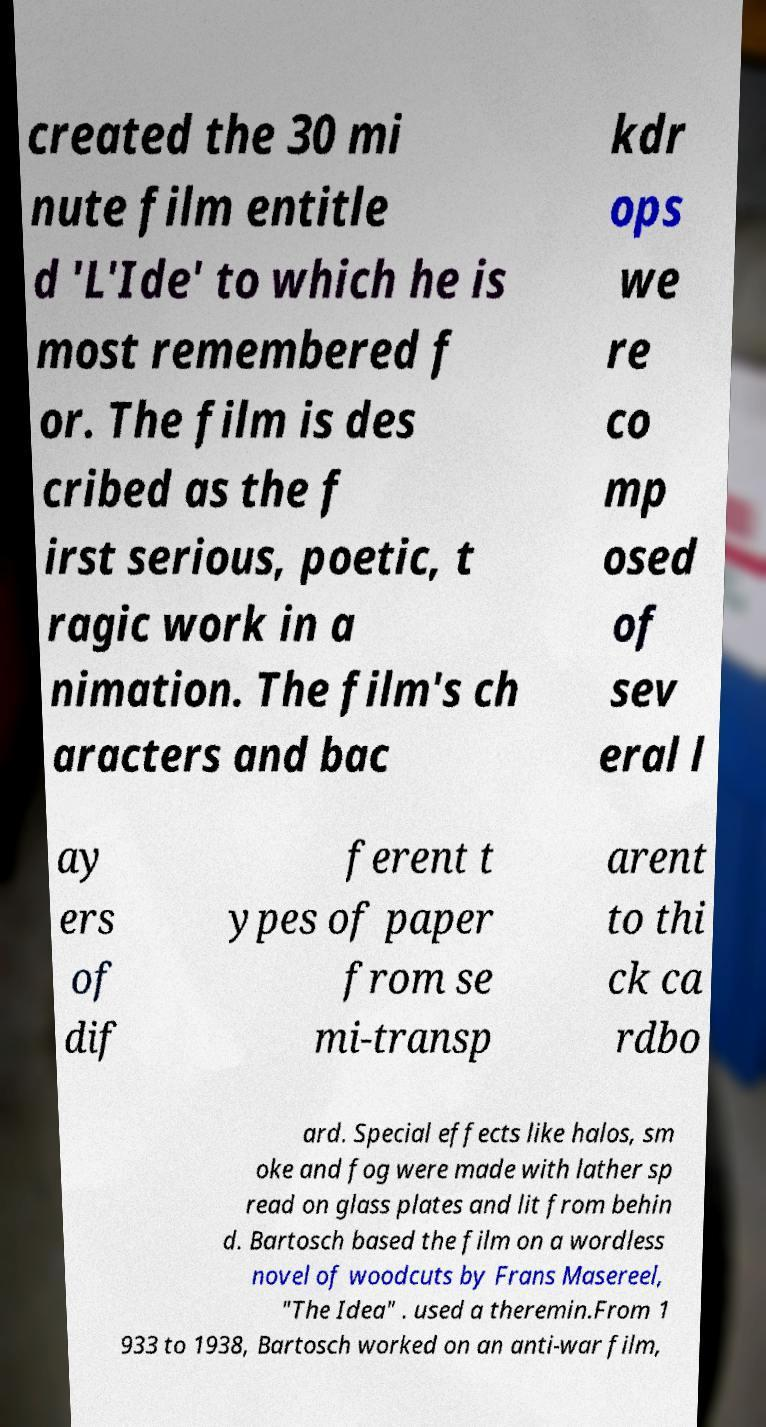There's text embedded in this image that I need extracted. Can you transcribe it verbatim? created the 30 mi nute film entitle d 'L'Ide' to which he is most remembered f or. The film is des cribed as the f irst serious, poetic, t ragic work in a nimation. The film's ch aracters and bac kdr ops we re co mp osed of sev eral l ay ers of dif ferent t ypes of paper from se mi-transp arent to thi ck ca rdbo ard. Special effects like halos, sm oke and fog were made with lather sp read on glass plates and lit from behin d. Bartosch based the film on a wordless novel of woodcuts by Frans Masereel, "The Idea" . used a theremin.From 1 933 to 1938, Bartosch worked on an anti-war film, 